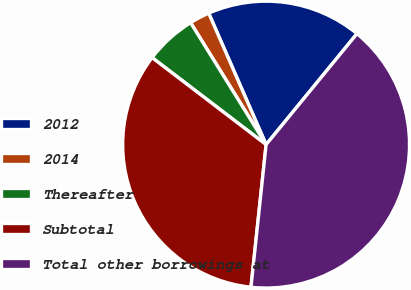Convert chart. <chart><loc_0><loc_0><loc_500><loc_500><pie_chart><fcel>2012<fcel>2014<fcel>Thereafter<fcel>Subtotal<fcel>Total other borrowings at<nl><fcel>17.48%<fcel>2.27%<fcel>5.8%<fcel>33.69%<fcel>40.76%<nl></chart> 